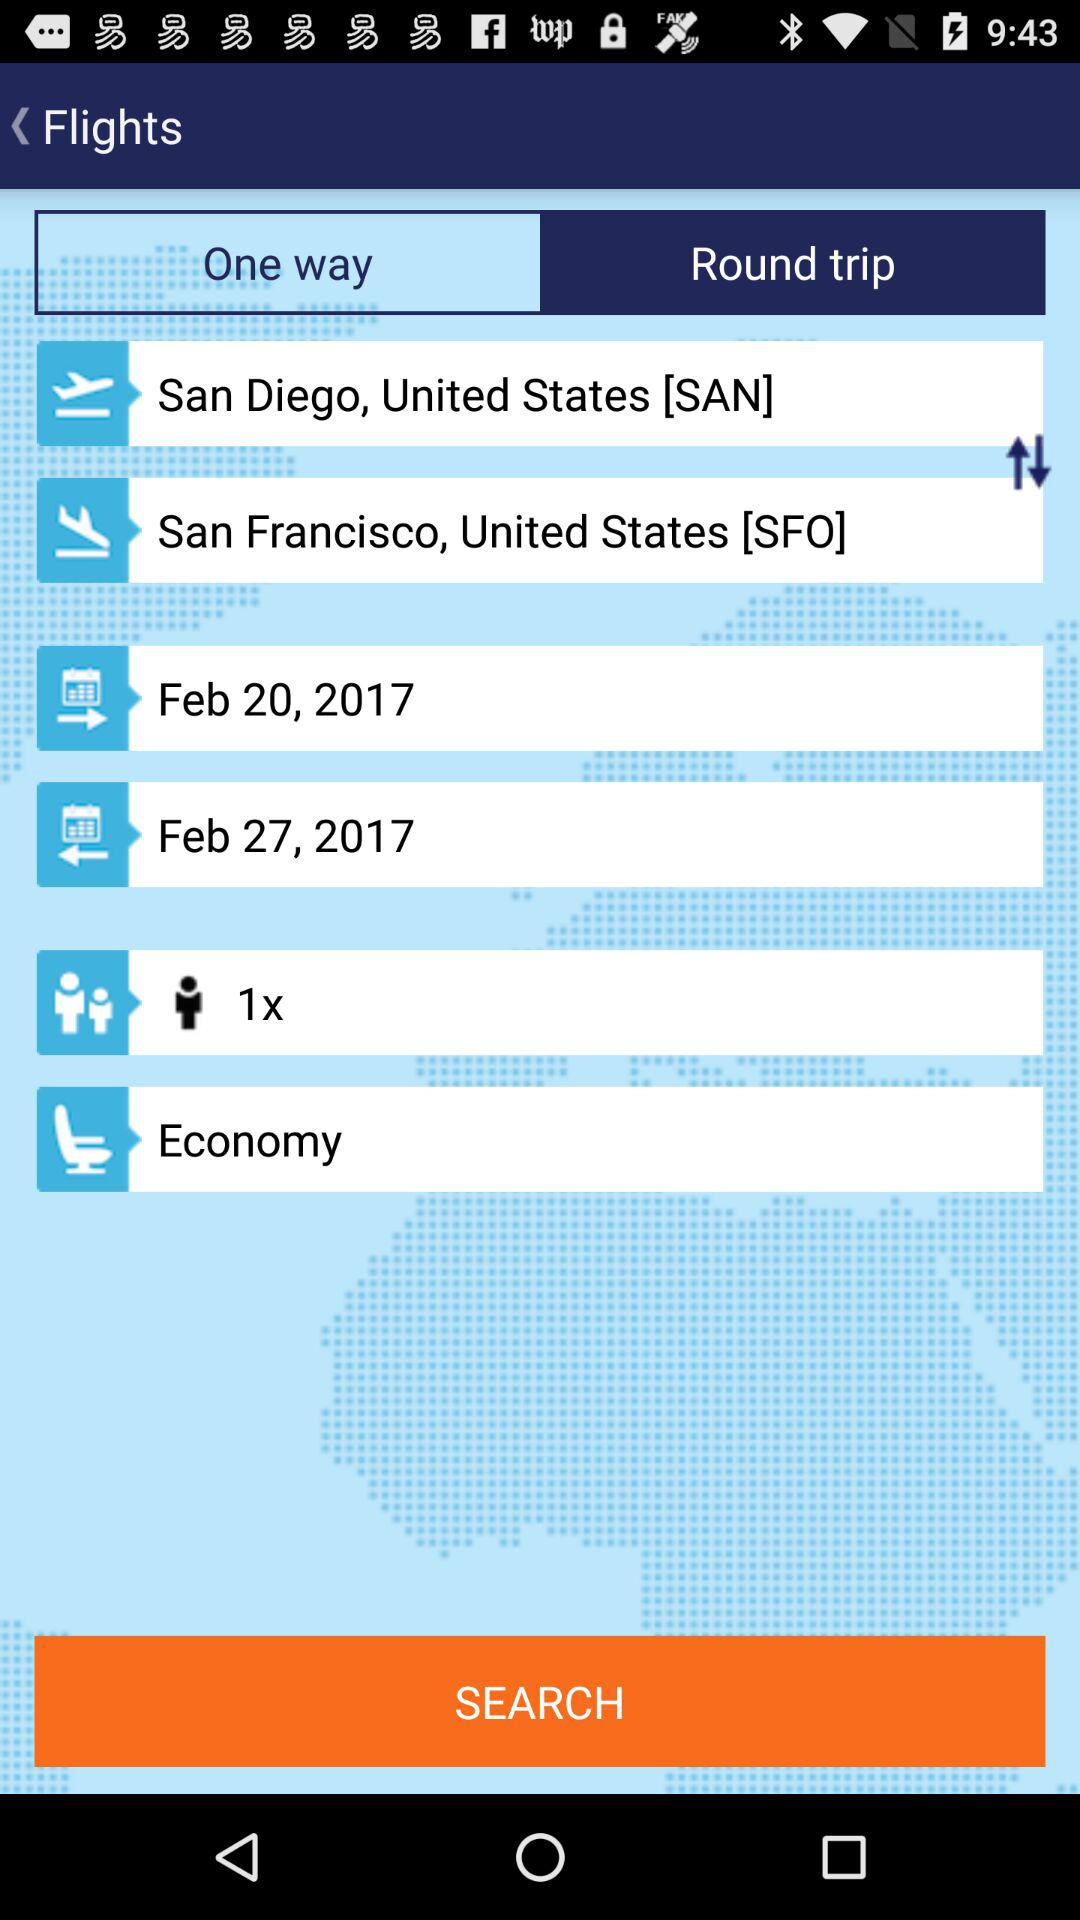What is the starting location? The starting location is San Diego, United States. 